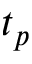<formula> <loc_0><loc_0><loc_500><loc_500>t _ { p }</formula> 